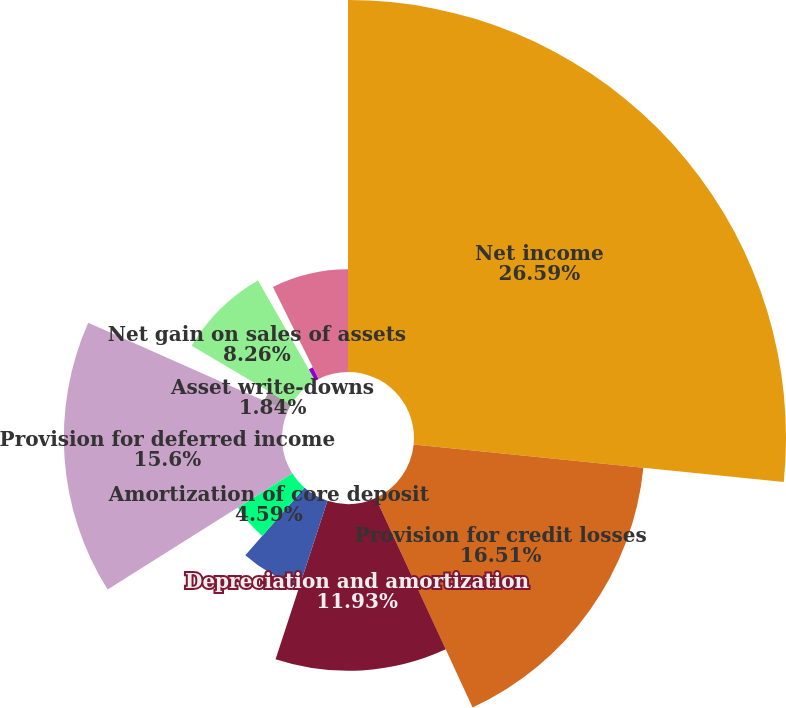<chart> <loc_0><loc_0><loc_500><loc_500><pie_chart><fcel>Net income<fcel>Provision for credit losses<fcel>Depreciation and amortization<fcel>Amortization of capitalized<fcel>Amortization of core deposit<fcel>Provision for deferred income<fcel>Asset write-downs<fcel>Net gain on sales of assets<fcel>Net change in accrued interest<fcel>Net change in other accrued<nl><fcel>26.6%<fcel>16.51%<fcel>11.93%<fcel>6.42%<fcel>4.59%<fcel>15.6%<fcel>1.84%<fcel>8.26%<fcel>0.92%<fcel>7.34%<nl></chart> 